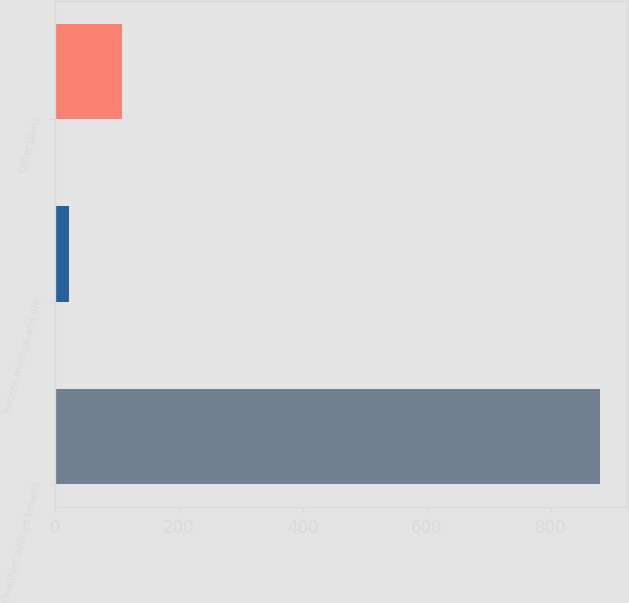Convert chart. <chart><loc_0><loc_0><loc_500><loc_500><bar_chart><fcel>Qualified defined benefit<fcel>Retiree medical and life<fcel>Other plans<nl><fcel>879<fcel>22<fcel>107.7<nl></chart> 